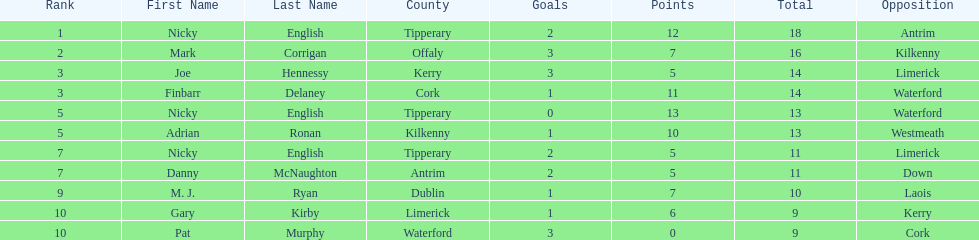Who was the top ranked player in a single game? Nicky English. 